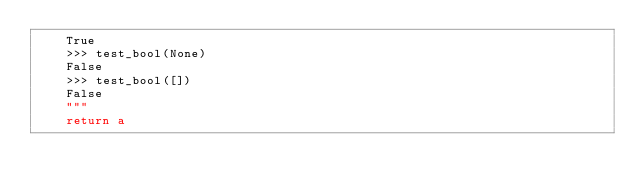Convert code to text. <code><loc_0><loc_0><loc_500><loc_500><_Cython_>    True
    >>> test_bool(None)
    False
    >>> test_bool([])
    False
    """
    return a
</code> 